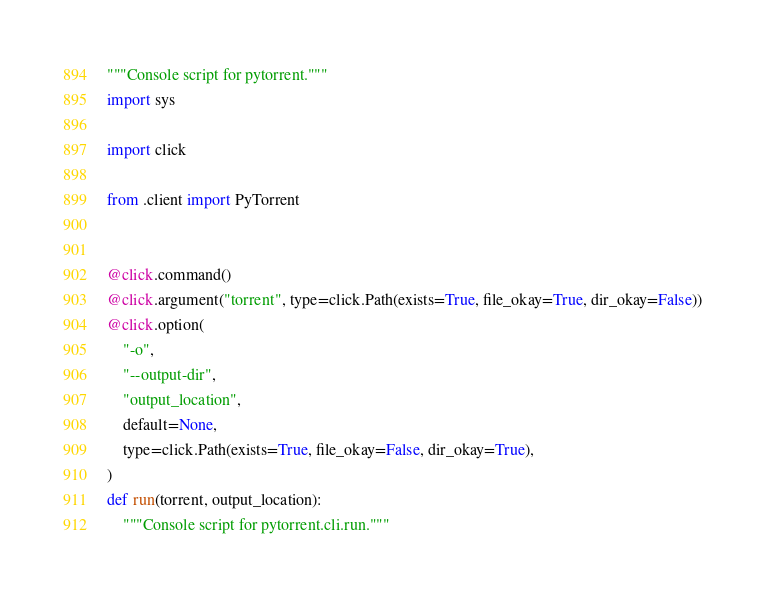Convert code to text. <code><loc_0><loc_0><loc_500><loc_500><_Python_>"""Console script for pytorrent."""
import sys

import click

from .client import PyTorrent


@click.command()
@click.argument("torrent", type=click.Path(exists=True, file_okay=True, dir_okay=False))
@click.option(
    "-o",
    "--output-dir",
    "output_location",
    default=None,
    type=click.Path(exists=True, file_okay=False, dir_okay=True),
)
def run(torrent, output_location):
    """Console script for pytorrent.cli.run."""</code> 